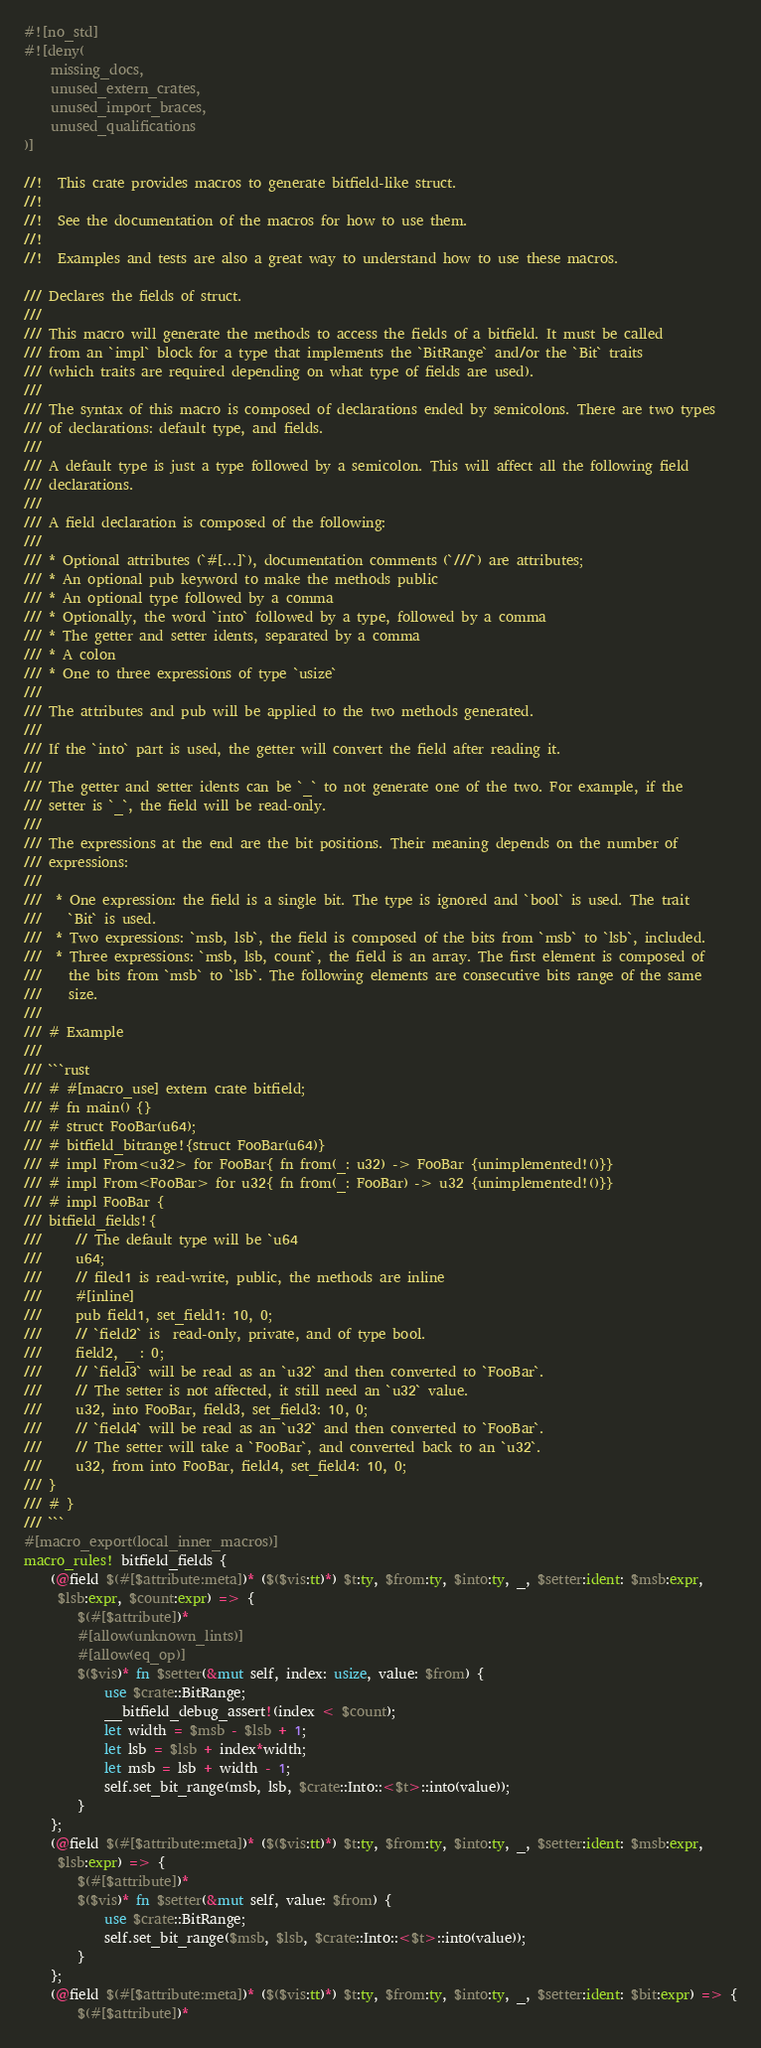Convert code to text. <code><loc_0><loc_0><loc_500><loc_500><_Rust_>#![no_std]
#![deny(
    missing_docs,
    unused_extern_crates,
    unused_import_braces,
    unused_qualifications
)]

//!  This crate provides macros to generate bitfield-like struct.
//!
//!  See the documentation of the macros for how to use them.
//!
//!  Examples and tests are also a great way to understand how to use these macros.

/// Declares the fields of struct.
///
/// This macro will generate the methods to access the fields of a bitfield. It must be called
/// from an `impl` block for a type that implements the `BitRange` and/or the `Bit` traits
/// (which traits are required depending on what type of fields are used).
///
/// The syntax of this macro is composed of declarations ended by semicolons. There are two types
/// of declarations: default type, and fields.
///
/// A default type is just a type followed by a semicolon. This will affect all the following field
/// declarations.
///
/// A field declaration is composed of the following:
///
/// * Optional attributes (`#[...]`), documentation comments (`///`) are attributes;
/// * An optional pub keyword to make the methods public
/// * An optional type followed by a comma
/// * Optionally, the word `into` followed by a type, followed by a comma
/// * The getter and setter idents, separated by a comma
/// * A colon
/// * One to three expressions of type `usize`
///
/// The attributes and pub will be applied to the two methods generated.
///
/// If the `into` part is used, the getter will convert the field after reading it.
///
/// The getter and setter idents can be `_` to not generate one of the two. For example, if the
/// setter is `_`, the field will be read-only.
///
/// The expressions at the end are the bit positions. Their meaning depends on the number of
/// expressions:
///
///  * One expression: the field is a single bit. The type is ignored and `bool` is used. The trait
///    `Bit` is used.
///  * Two expressions: `msb, lsb`, the field is composed of the bits from `msb` to `lsb`, included.
///  * Three expressions: `msb, lsb, count`, the field is an array. The first element is composed of
///    the bits from `msb` to `lsb`. The following elements are consecutive bits range of the same
///    size.
///
/// # Example
///
/// ```rust
/// # #[macro_use] extern crate bitfield;
/// # fn main() {}
/// # struct FooBar(u64);
/// # bitfield_bitrange!{struct FooBar(u64)}
/// # impl From<u32> for FooBar{ fn from(_: u32) -> FooBar {unimplemented!()}}
/// # impl From<FooBar> for u32{ fn from(_: FooBar) -> u32 {unimplemented!()}}
/// # impl FooBar {
/// bitfield_fields!{
///     // The default type will be `u64
///     u64;
///     // filed1 is read-write, public, the methods are inline
///     #[inline]
///     pub field1, set_field1: 10, 0;
///     // `field2` is  read-only, private, and of type bool.
///     field2, _ : 0;
///     // `field3` will be read as an `u32` and then converted to `FooBar`.
///     // The setter is not affected, it still need an `u32` value.
///     u32, into FooBar, field3, set_field3: 10, 0;
///     // `field4` will be read as an `u32` and then converted to `FooBar`.
///     // The setter will take a `FooBar`, and converted back to an `u32`.
///     u32, from into FooBar, field4, set_field4: 10, 0;
/// }
/// # }
/// ```
#[macro_export(local_inner_macros)]
macro_rules! bitfield_fields {
    (@field $(#[$attribute:meta])* ($($vis:tt)*) $t:ty, $from:ty, $into:ty, _, $setter:ident: $msb:expr,
     $lsb:expr, $count:expr) => {
        $(#[$attribute])*
        #[allow(unknown_lints)]
        #[allow(eq_op)]
        $($vis)* fn $setter(&mut self, index: usize, value: $from) {
            use $crate::BitRange;
            __bitfield_debug_assert!(index < $count);
            let width = $msb - $lsb + 1;
            let lsb = $lsb + index*width;
            let msb = lsb + width - 1;
            self.set_bit_range(msb, lsb, $crate::Into::<$t>::into(value));
        }
    };
    (@field $(#[$attribute:meta])* ($($vis:tt)*) $t:ty, $from:ty, $into:ty, _, $setter:ident: $msb:expr,
     $lsb:expr) => {
        $(#[$attribute])*
        $($vis)* fn $setter(&mut self, value: $from) {
            use $crate::BitRange;
            self.set_bit_range($msb, $lsb, $crate::Into::<$t>::into(value));
        }
    };
    (@field $(#[$attribute:meta])* ($($vis:tt)*) $t:ty, $from:ty, $into:ty, _, $setter:ident: $bit:expr) => {
        $(#[$attribute])*</code> 